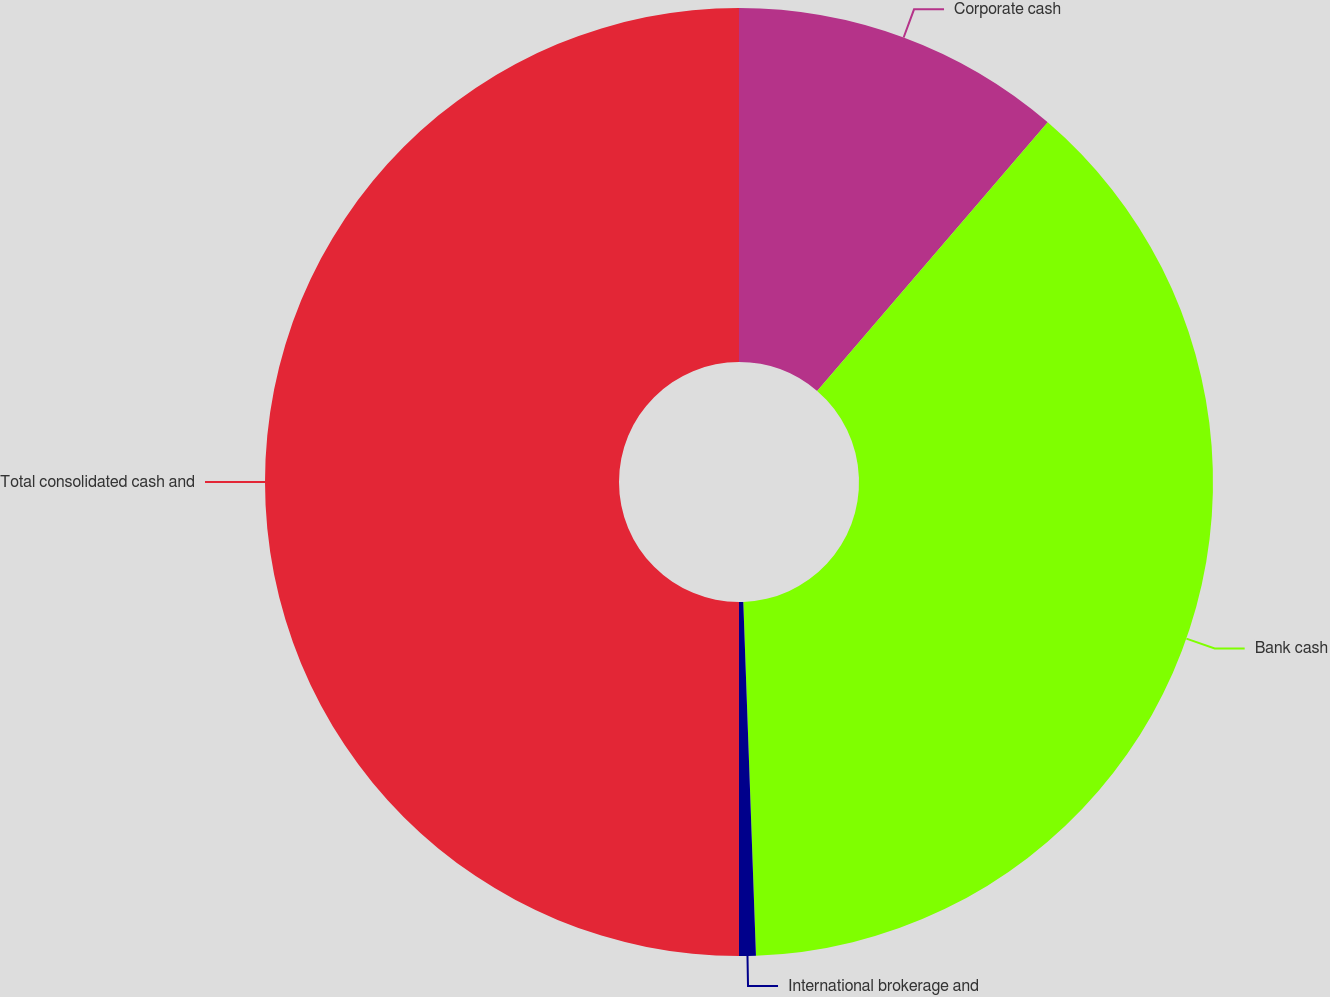Convert chart. <chart><loc_0><loc_0><loc_500><loc_500><pie_chart><fcel>Corporate cash<fcel>Bank cash<fcel>International brokerage and<fcel>Total consolidated cash and<nl><fcel>11.29%<fcel>38.14%<fcel>0.57%<fcel>50.0%<nl></chart> 